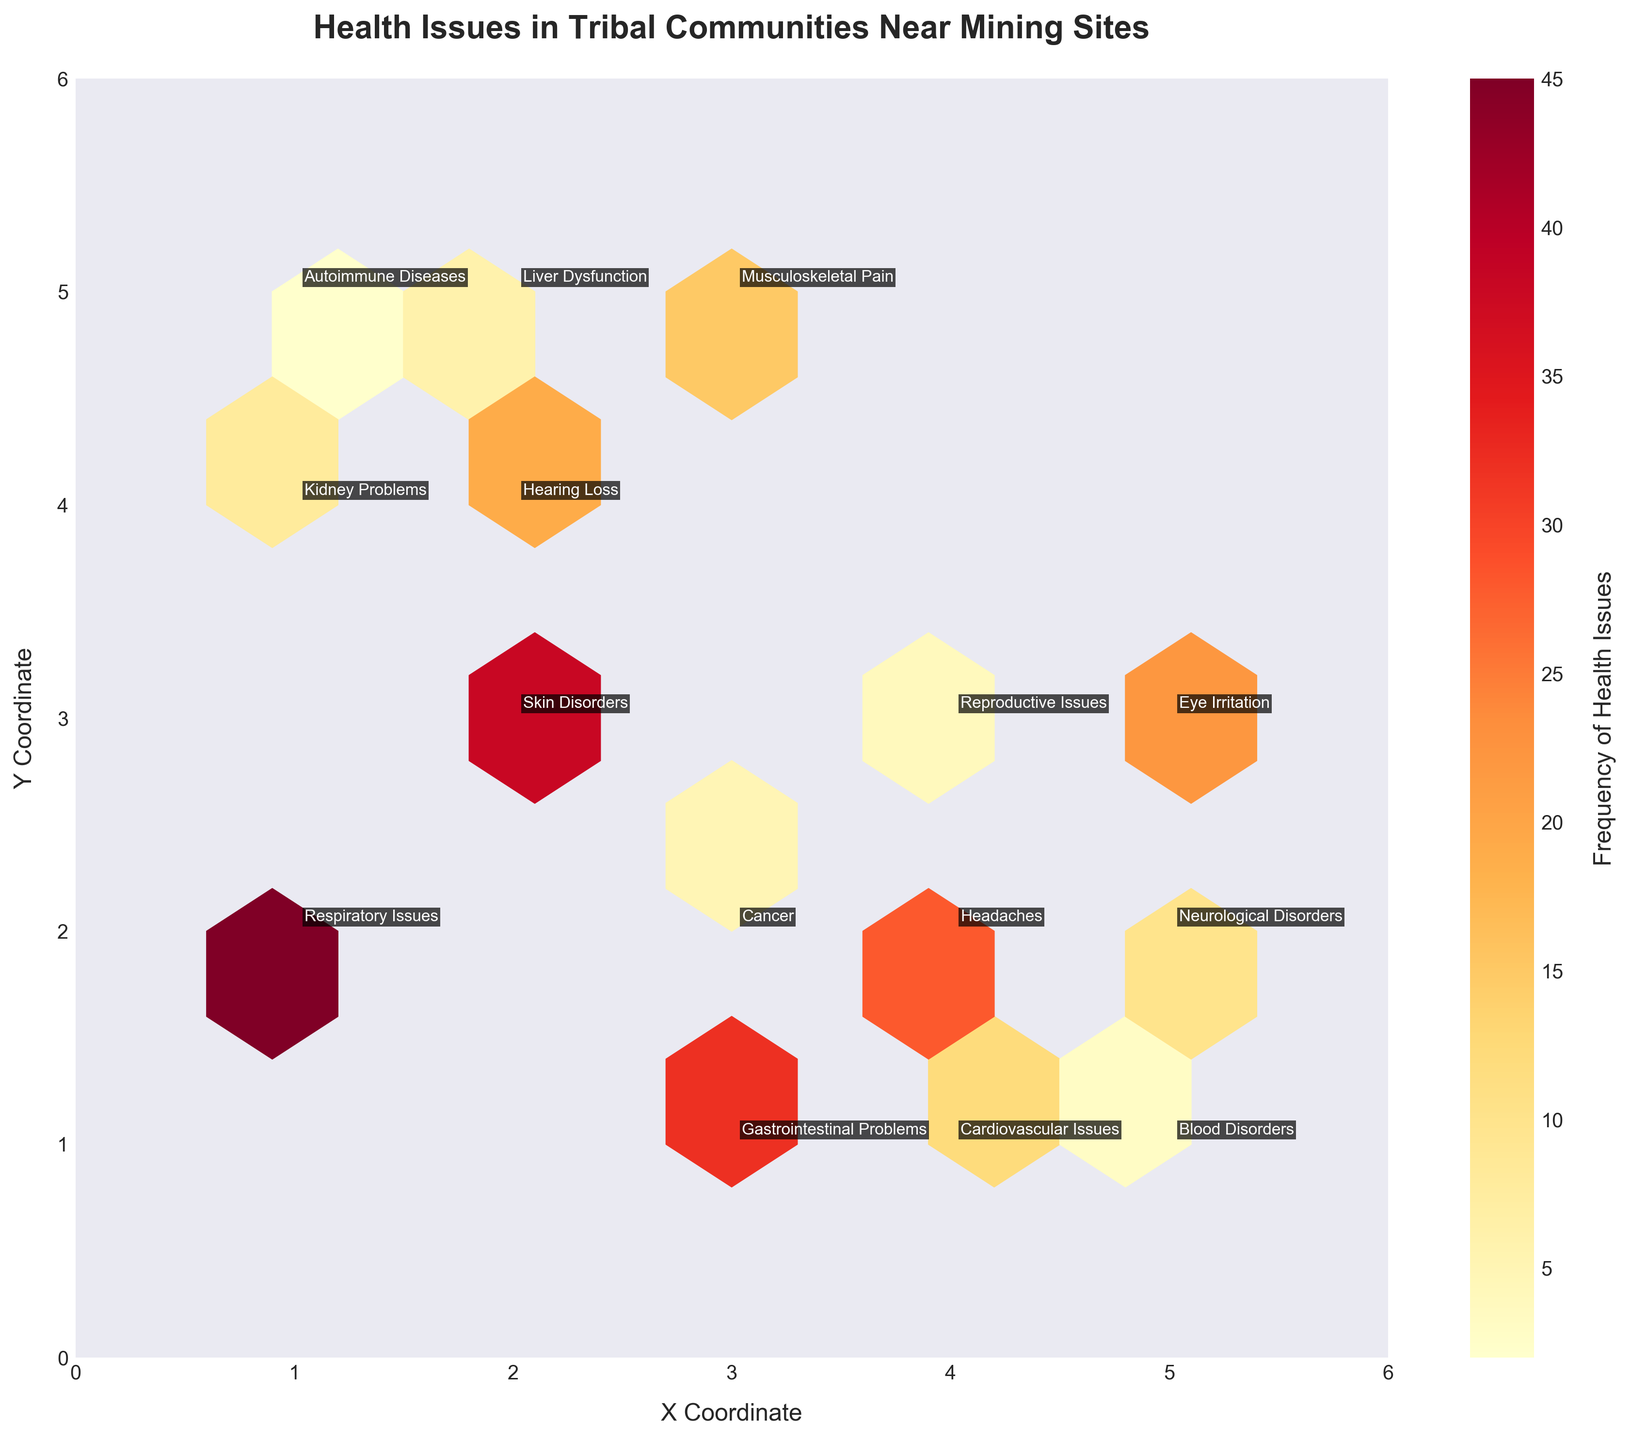What is the title of the figure? The title can be found at the top of the figure, it generally describes the main insight or focus of the plot.
Answer: Health Issues in Tribal Communities Near Mining Sites What does the color intensity represent in the hexbin plot? In a hexbin plot, the color intensity represents the frequency of health issues reported within each hexbin. The color bar on the side indicates that higher frequencies are represented by more intense (darker) colors.
Answer: Frequency of Health Issues Which ailment has the highest frequency according to the plot? By observing the plot, the hexbin with the highest color intensity (darkest shade) around coordinates (1, 2) is annotated with "Respiratory Issues" and a frequency of 45.
Answer: Respiratory Issues What do the x and y axes represent in the figure? The x and y labels represent coordinates on which different health issues are plotted. Their exact significance is not described, but they enable positioning different types of health issues spatially.
Answer: X and Y Coordinates Which ailment is positioned at the coordinate (2, 3) and what is its frequency? By looking at the coordinate (2, 3) on the plot, we can see an annotation indicating "Skin Disorders" which has a corresponding frequency of 38.
Answer: Skin Disorders with a frequency of 38 Compare the frequency of 'Eye Irritation' and 'Gastrointestinal Problems'. Which one is higher and by how much? Locate 'Eye Irritation' and 'Gastrointestinal Problems' on the plot. 'Eye Irritation' has a frequency of 22 (at 5,3) while 'Gastrointestinal Problems' has a frequency of 32 (at 3,1). The difference is 32 - 22.
Answer: Gastrointestinal Problems is higher by 10 Which ailments fall between the coordinates (2, 4) and (3, 5)? Checking the annotated values near coordinates (2, 4) and (3, 5), we find that "Hearing Loss" (2, 4) and "Musculoskeletal Pain" (3, 5) fall in this range.
Answer: Hearing Loss and Musculoskeletal Pain If you sum the frequencies of 'Headaches' and 'Neurological Disorders', what is the total? Find the frequencies of 'Headaches' (28 at 4,2) and 'Neurological Disorders' (10 at 5,2), then sum them up: 28 + 10.
Answer: 38 Which ailment has the lowest frequency and where is it located? Observing the plot, the ailment with the lowest frequency is "Autoimmune Diseases" which has a frequency of 2 and is located at coordinate (1,5).
Answer: Autoimmune Diseases at (1,5) Are there any ailments located at coordinate (3, 2)? If so, name it and provide the frequency. By checking the coordinate (3, 2) on the figure, we find that the ailment located here is "Cancer" with a frequency of 5.
Answer: Cancer with a frequency of 5 